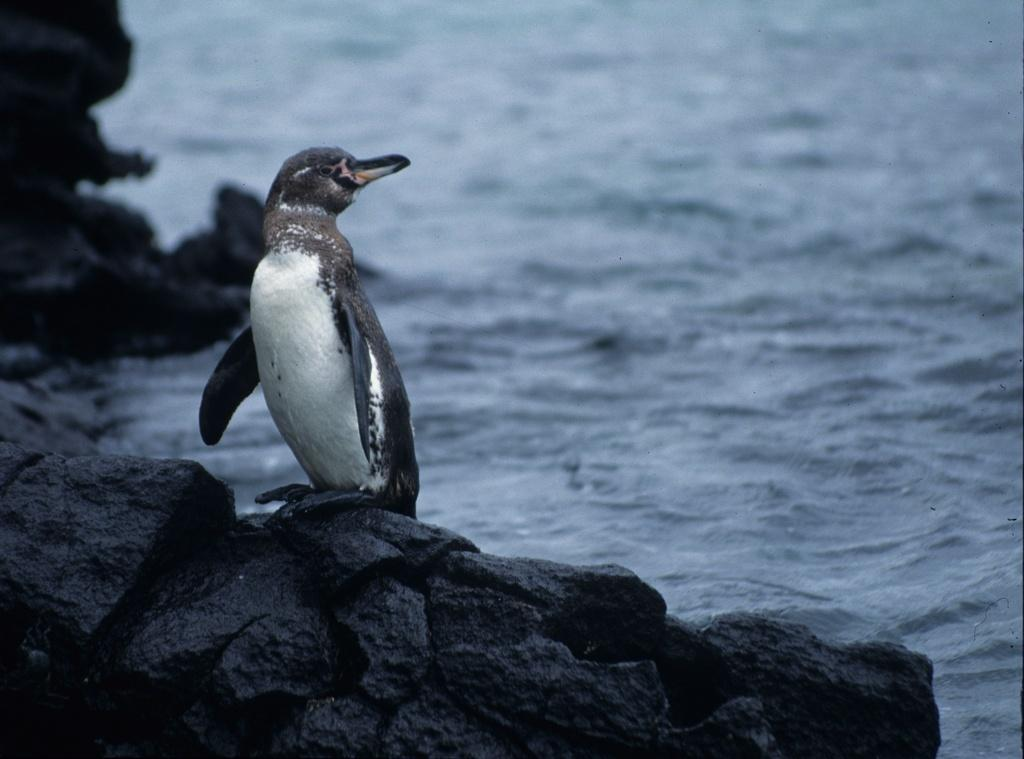What animal is present in the image? There is a penguin in the image. What is the penguin standing on? The penguin is standing on a rock. What can be seen in the background of the image? The background of the image is blurred. What type of comfort does the penguin provide for the uncle in the image? There is no uncle present in the image, and therefore no interaction between the penguin and an uncle can be observed. 